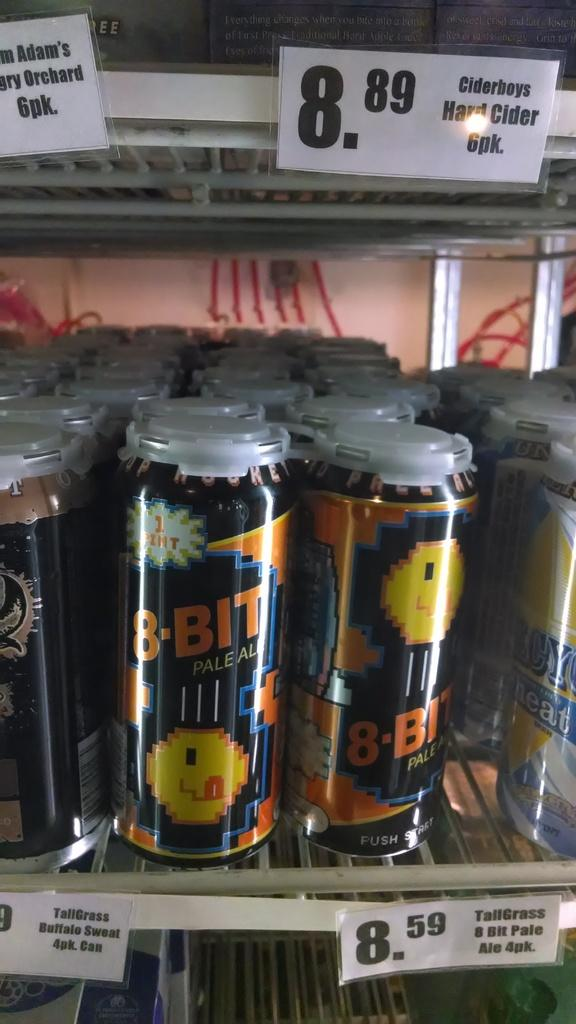<image>
Present a compact description of the photo's key features. A 4 pack of TallGrass 8 bit pale ale costs 8,59 